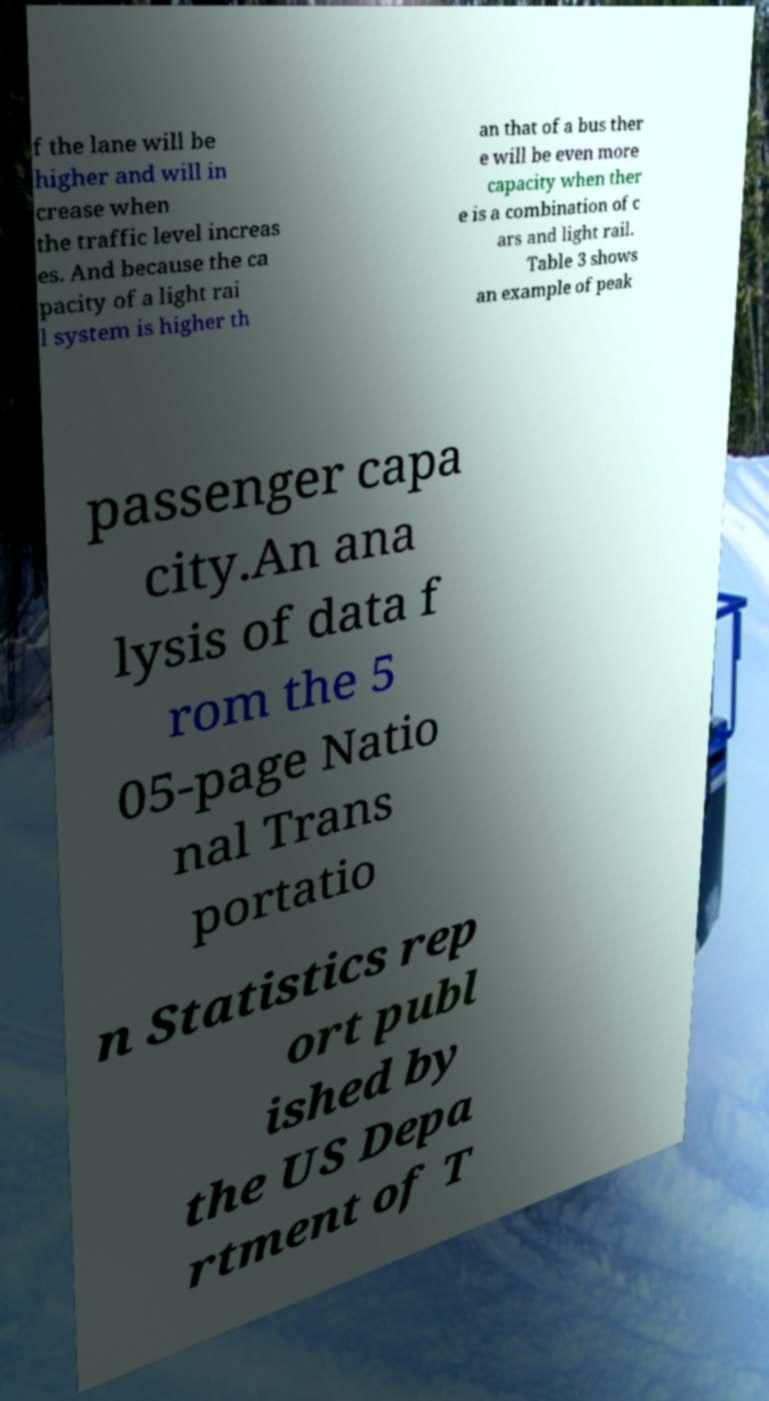Could you assist in decoding the text presented in this image and type it out clearly? f the lane will be higher and will in crease when the traffic level increas es. And because the ca pacity of a light rai l system is higher th an that of a bus ther e will be even more capacity when ther e is a combination of c ars and light rail. Table 3 shows an example of peak passenger capa city.An ana lysis of data f rom the 5 05-page Natio nal Trans portatio n Statistics rep ort publ ished by the US Depa rtment of T 